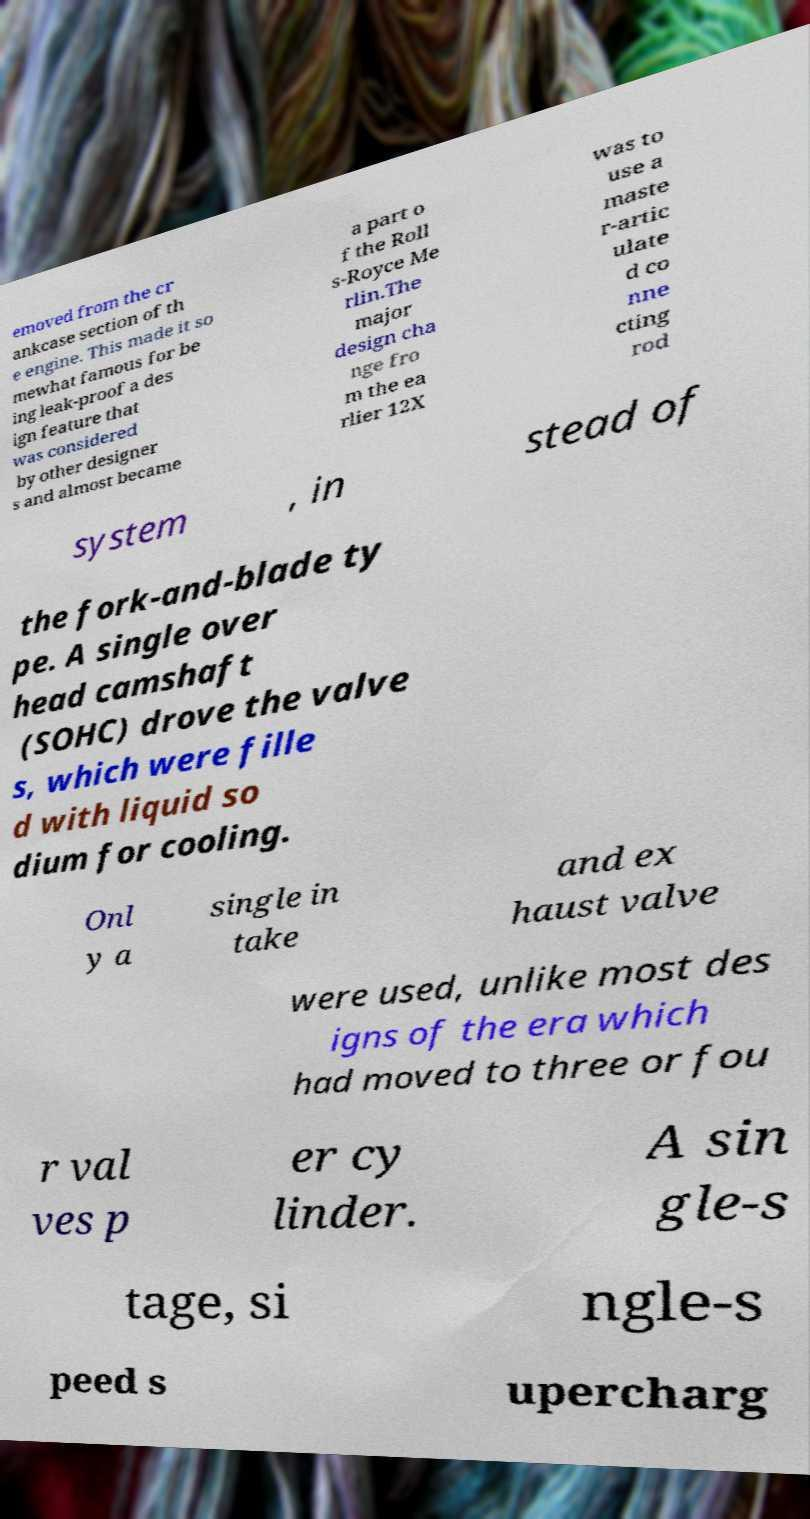Could you assist in decoding the text presented in this image and type it out clearly? emoved from the cr ankcase section of th e engine. This made it so mewhat famous for be ing leak-proof a des ign feature that was considered by other designer s and almost became a part o f the Roll s-Royce Me rlin.The major design cha nge fro m the ea rlier 12X was to use a maste r-artic ulate d co nne cting rod system , in stead of the fork-and-blade ty pe. A single over head camshaft (SOHC) drove the valve s, which were fille d with liquid so dium for cooling. Onl y a single in take and ex haust valve were used, unlike most des igns of the era which had moved to three or fou r val ves p er cy linder. A sin gle-s tage, si ngle-s peed s upercharg 